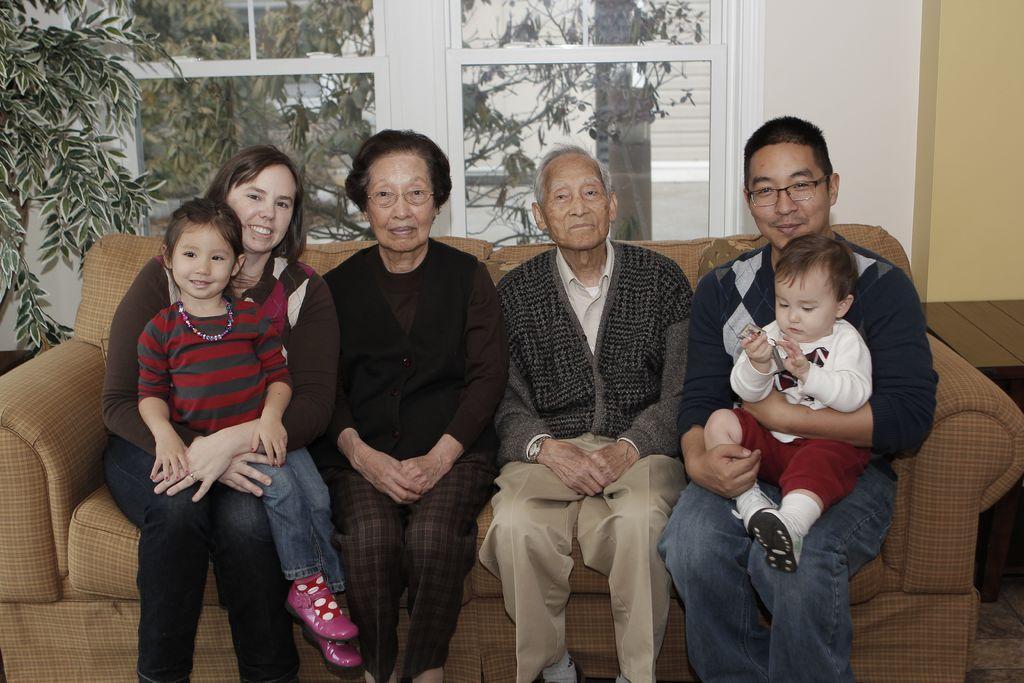How would you summarize this image in a sentence or two? 4 Persons are sitting on the sofa by holding the 2 kids in their laps. Behind them there are glass windows. Outside there are trees in this image. 